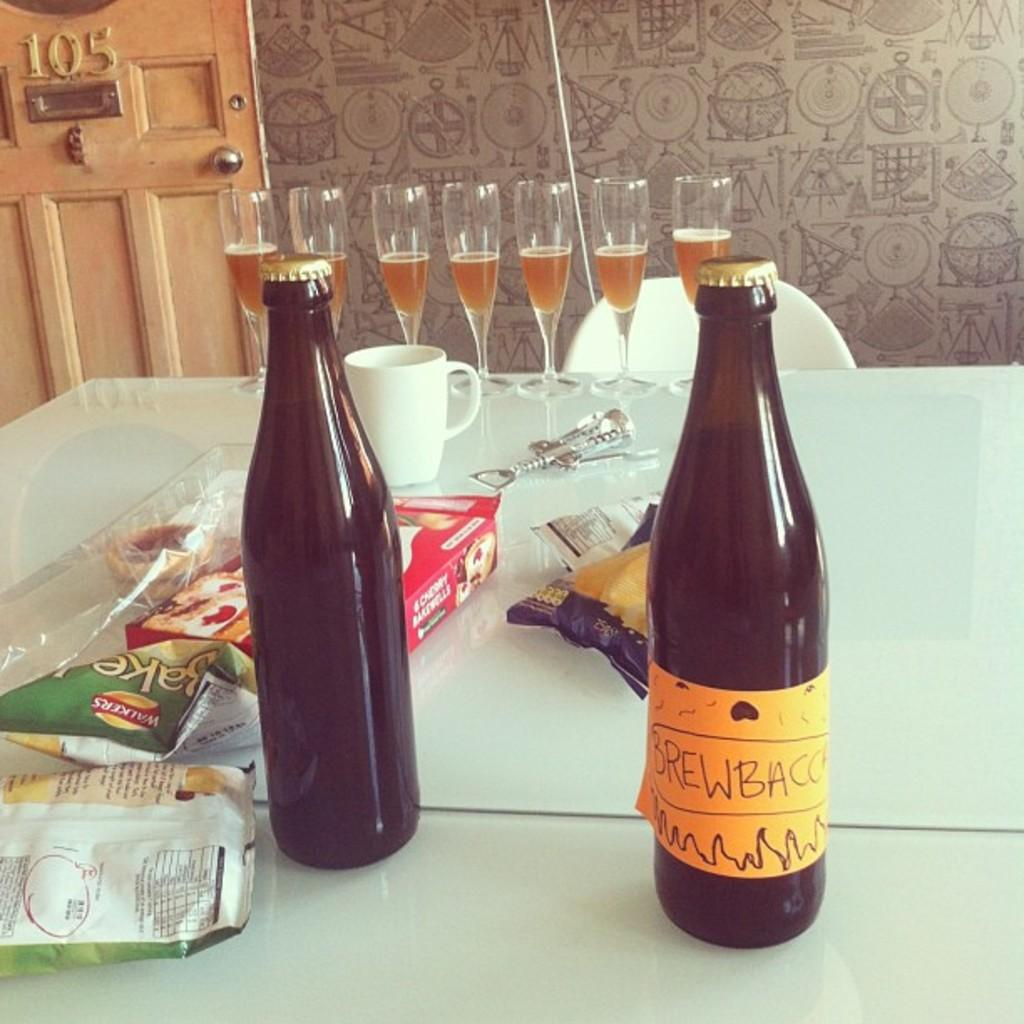<image>
Relay a brief, clear account of the picture shown. A bag of Walkers chips is on a white table by some bottles. 